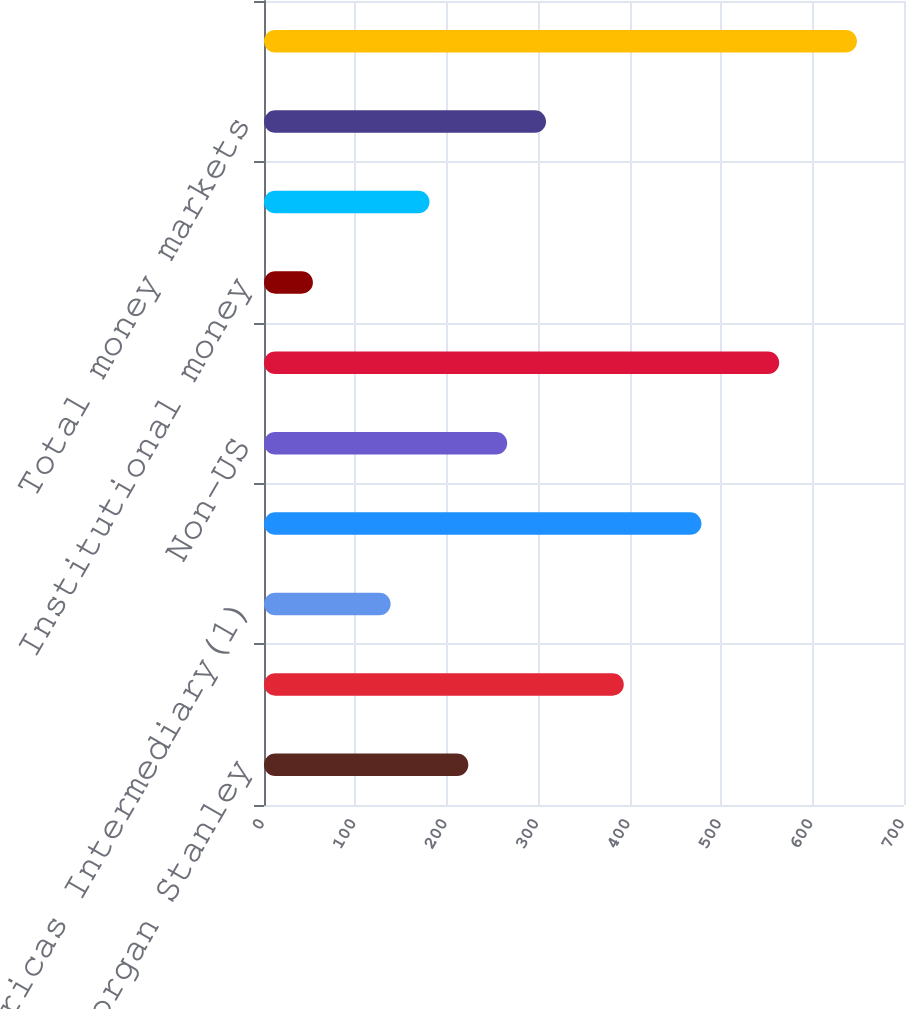<chart> <loc_0><loc_0><loc_500><loc_500><bar_chart><fcel>Americas Retail Morgan Stanley<fcel>Americas Retail Van Kampen<fcel>Americas Intermediary(1)<fcel>US Institutional<fcel>Non-US<fcel>Total long-term assets under<fcel>Institutional money<fcel>Retail money markets<fcel>Total money markets<fcel>Total assets under management<nl><fcel>223.5<fcel>393.5<fcel>138.5<fcel>478.5<fcel>266<fcel>563.5<fcel>53.5<fcel>181<fcel>308.5<fcel>648.5<nl></chart> 